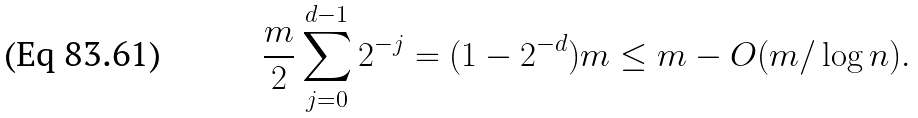<formula> <loc_0><loc_0><loc_500><loc_500>\frac { m } 2 \sum _ { j = 0 } ^ { d - 1 } 2 ^ { - j } = ( 1 - 2 ^ { - d } ) m \leq m - O ( m / \log n ) .</formula> 